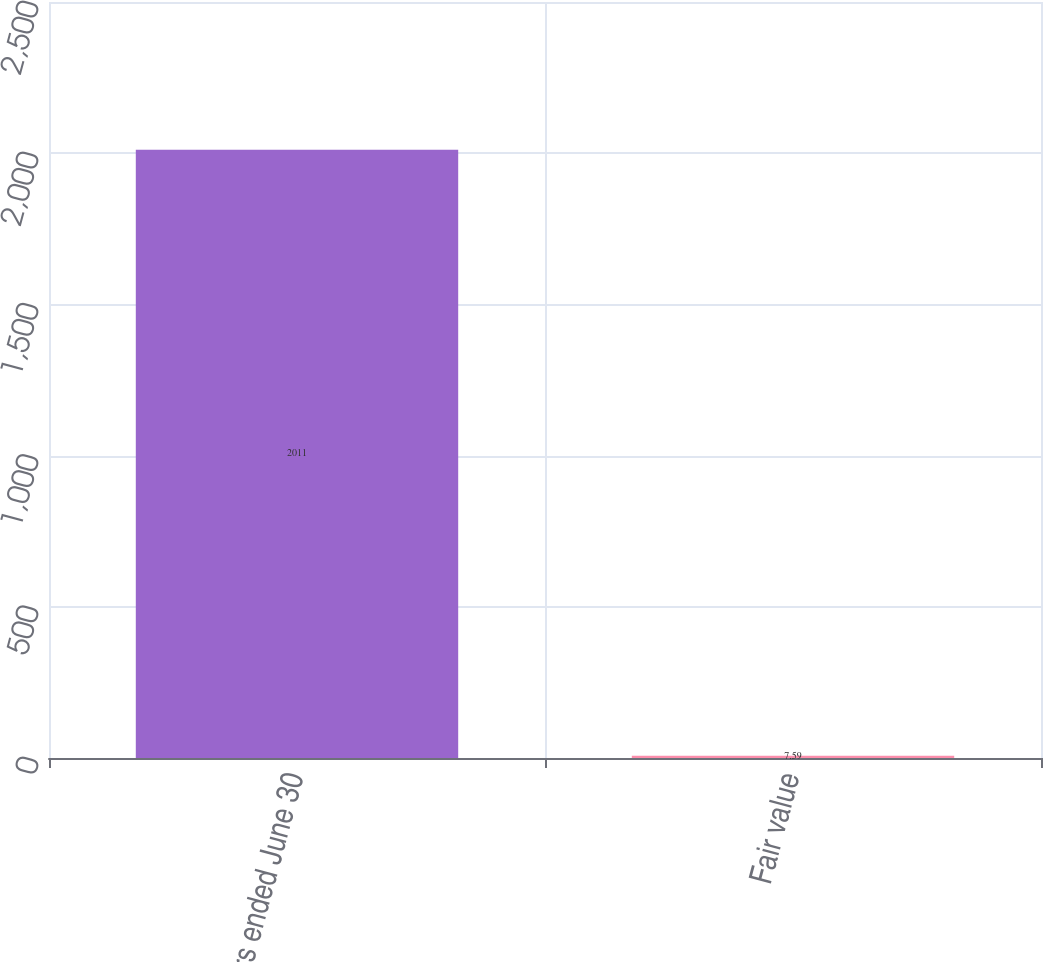Convert chart. <chart><loc_0><loc_0><loc_500><loc_500><bar_chart><fcel>Years ended June 30<fcel>Fair value<nl><fcel>2011<fcel>7.59<nl></chart> 